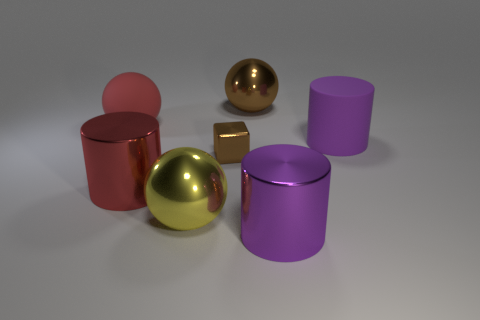Subtract 1 cylinders. How many cylinders are left? 2 Add 3 large purple metal blocks. How many objects exist? 10 Subtract all spheres. How many objects are left? 4 Add 4 small brown metal things. How many small brown metal things exist? 5 Subtract 0 blue balls. How many objects are left? 7 Subtract all big brown spheres. Subtract all big rubber cylinders. How many objects are left? 5 Add 5 brown objects. How many brown objects are left? 7 